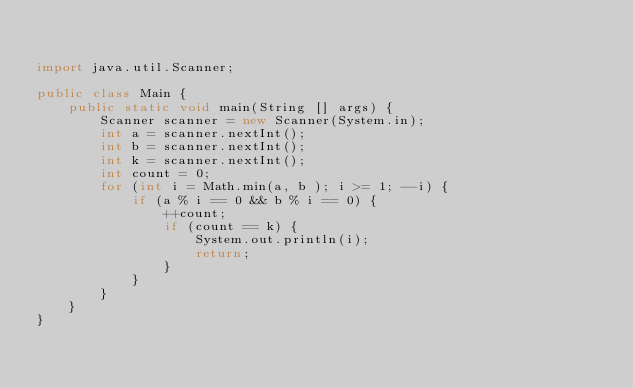<code> <loc_0><loc_0><loc_500><loc_500><_Java_>

import java.util.Scanner;

public class Main {
    public static void main(String [] args) {
        Scanner scanner = new Scanner(System.in);
        int a = scanner.nextInt();
        int b = scanner.nextInt();
        int k = scanner.nextInt();
        int count = 0;
        for (int i = Math.min(a, b ); i >= 1; --i) {
            if (a % i == 0 && b % i == 0) {
                ++count;
                if (count == k) {
                    System.out.println(i);
                    return;
                }
            }
        }
    }
}
</code> 